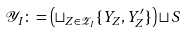Convert formula to latex. <formula><loc_0><loc_0><loc_500><loc_500>\mathcal { Y } _ { I } \colon = \left ( \sqcup _ { Z \in \mathcal { Z } _ { I } } \{ Y _ { Z } , Y ^ { \prime } _ { Z } \} \right ) \sqcup S</formula> 